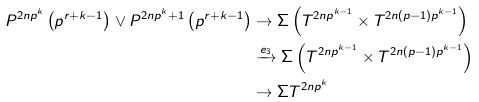Convert formula to latex. <formula><loc_0><loc_0><loc_500><loc_500>P ^ { 2 n p ^ { k } } \left ( p ^ { r + k - 1 } \right ) \vee P ^ { 2 n p ^ { k } + 1 } \left ( p ^ { r + k - 1 } \right ) & \rightarrow \Sigma \left ( T ^ { 2 n p ^ { k - 1 } } \times T ^ { 2 n ( p - 1 ) p ^ { k - 1 } } \right ) \\ & \xrightarrow { e _ { 3 } } \Sigma \left ( T ^ { 2 n p ^ { k - 1 } } \times T ^ { 2 n ( p - 1 ) p ^ { k - 1 } } \right ) \\ & \rightarrow \Sigma T ^ { 2 n p ^ { k } }</formula> 